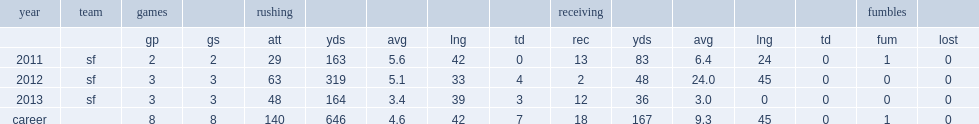How many yards did gore have in his career? 167.0. 